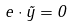Convert formula to latex. <formula><loc_0><loc_0><loc_500><loc_500>e \cdot \tilde { y } = 0</formula> 